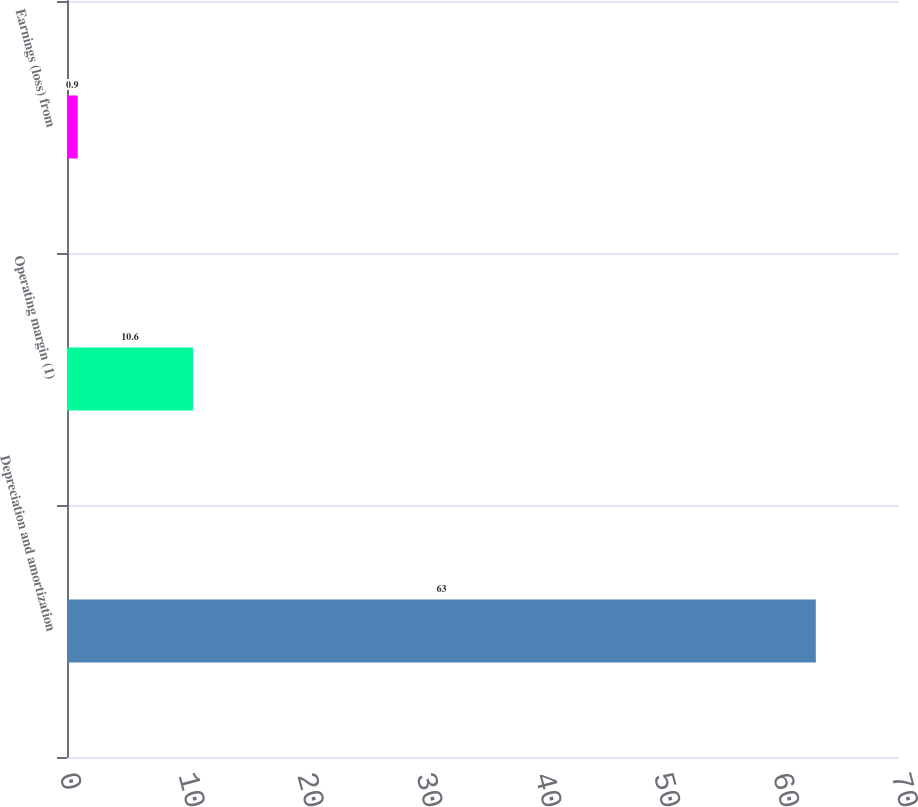Convert chart. <chart><loc_0><loc_0><loc_500><loc_500><bar_chart><fcel>Depreciation and amortization<fcel>Operating margin (1)<fcel>Earnings (loss) from<nl><fcel>63<fcel>10.6<fcel>0.9<nl></chart> 